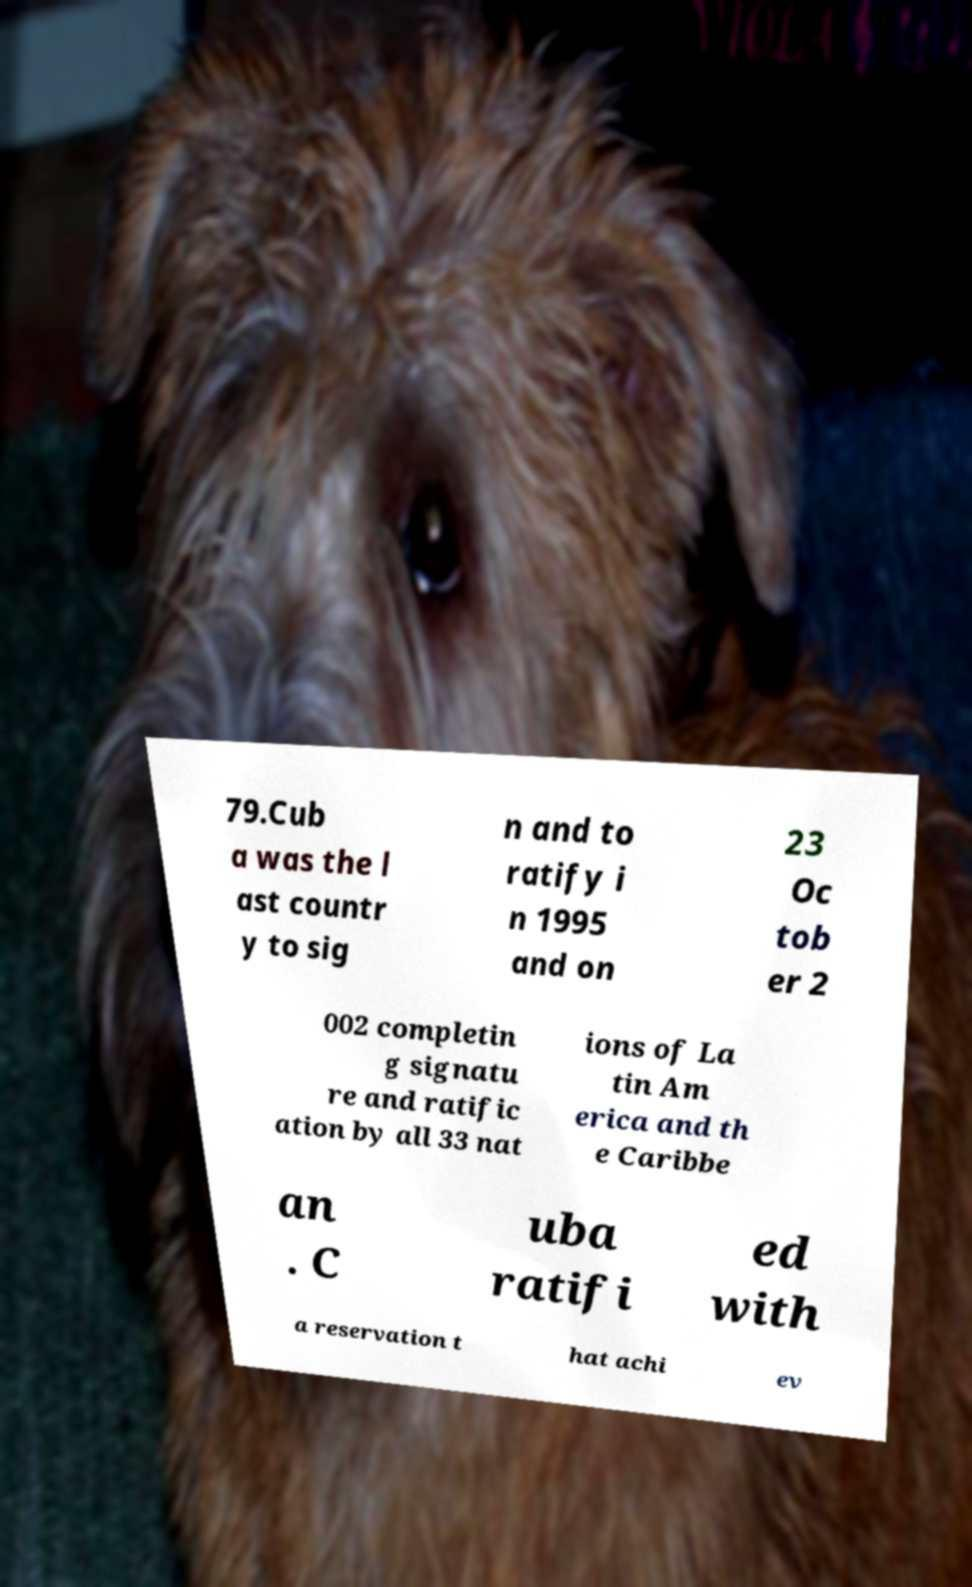Could you extract and type out the text from this image? 79.Cub a was the l ast countr y to sig n and to ratify i n 1995 and on 23 Oc tob er 2 002 completin g signatu re and ratific ation by all 33 nat ions of La tin Am erica and th e Caribbe an . C uba ratifi ed with a reservation t hat achi ev 